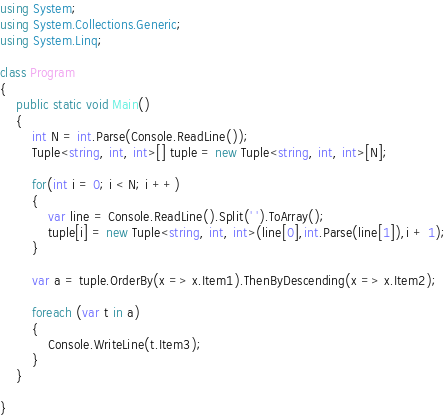<code> <loc_0><loc_0><loc_500><loc_500><_C#_>using System;
using System.Collections.Generic;
using System.Linq;

class Program
{
    public static void Main()
    {
        int N = int.Parse(Console.ReadLine());
        Tuple<string, int, int>[] tuple = new Tuple<string, int, int>[N];

        for(int i = 0; i < N; i ++)
        {
            var line = Console.ReadLine().Split(' ').ToArray();
            tuple[i] = new Tuple<string, int, int>(line[0],int.Parse(line[1]),i + 1);
        }

        var a = tuple.OrderBy(x => x.Item1).ThenByDescending(x => x.Item2);

        foreach (var t in a)
        {
            Console.WriteLine(t.Item3);
        }
    }

}</code> 